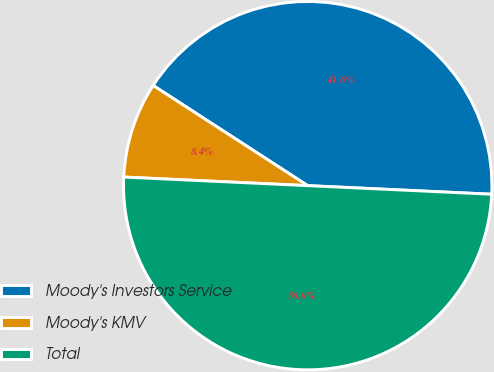<chart> <loc_0><loc_0><loc_500><loc_500><pie_chart><fcel>Moody's Investors Service<fcel>Moody's KMV<fcel>Total<nl><fcel>41.59%<fcel>8.41%<fcel>50.0%<nl></chart> 